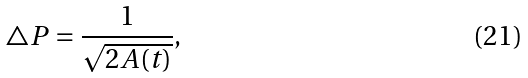Convert formula to latex. <formula><loc_0><loc_0><loc_500><loc_500>\triangle P = \frac { 1 } { \sqrt { 2 A ( t ) } } ,</formula> 